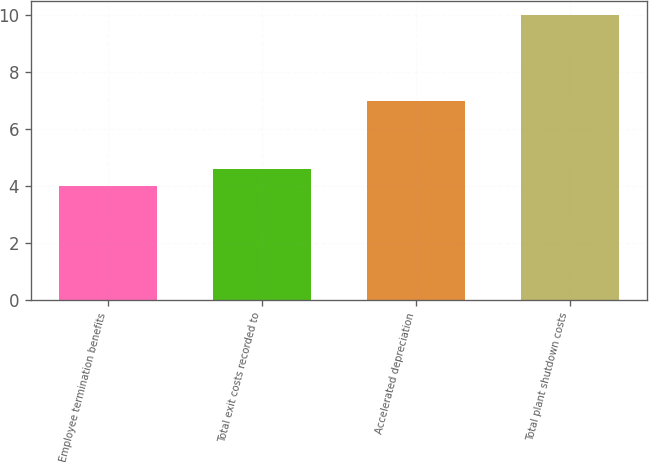<chart> <loc_0><loc_0><loc_500><loc_500><bar_chart><fcel>Employee termination benefits<fcel>Total exit costs recorded to<fcel>Accelerated depreciation<fcel>Total plant shutdown costs<nl><fcel>4<fcel>4.6<fcel>7<fcel>10<nl></chart> 